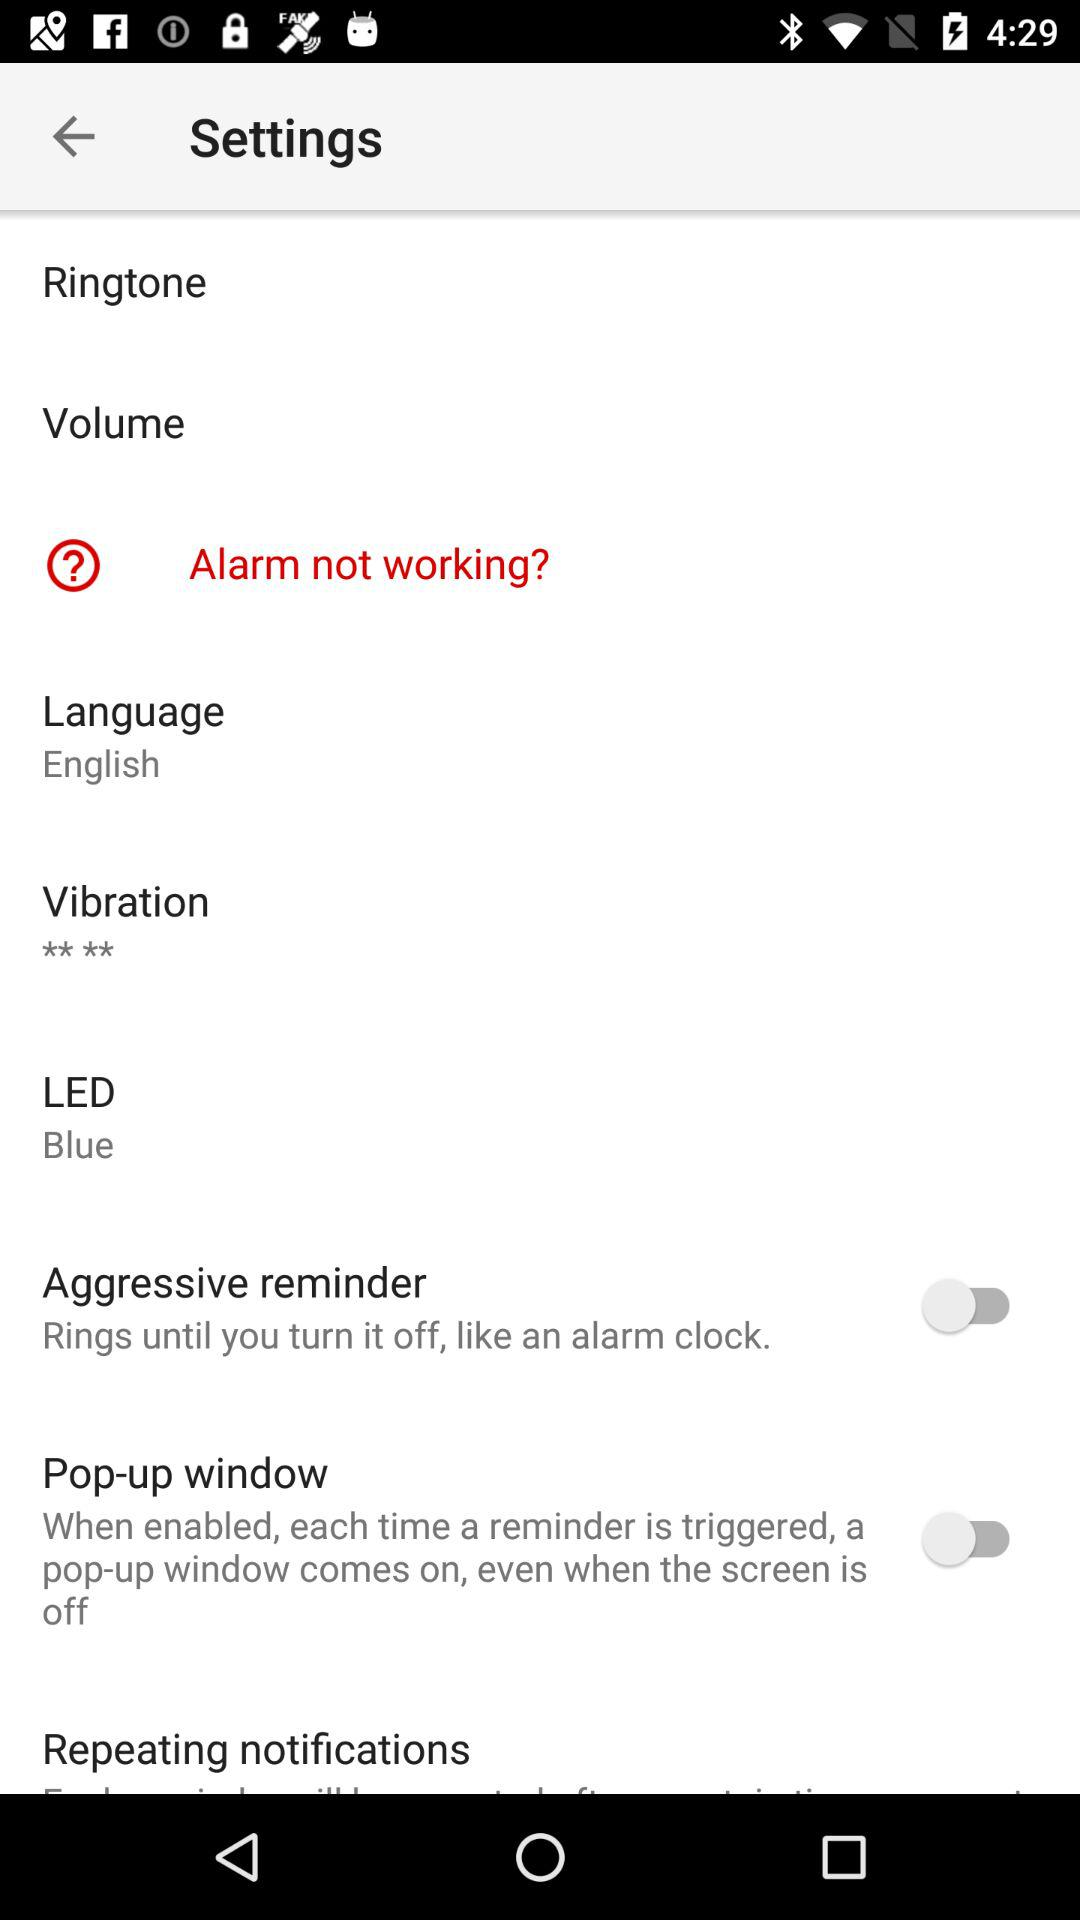Is the alarm working? The alarm is not working. 